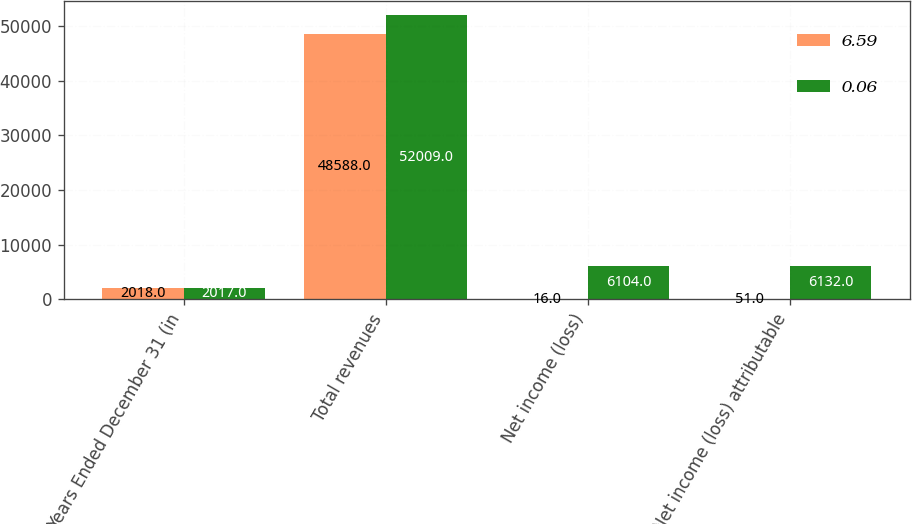Convert chart. <chart><loc_0><loc_0><loc_500><loc_500><stacked_bar_chart><ecel><fcel>Years Ended December 31 (in<fcel>Total revenues<fcel>Net income (loss)<fcel>Net income (loss) attributable<nl><fcel>6.59<fcel>2018<fcel>48588<fcel>16<fcel>51<nl><fcel>0.06<fcel>2017<fcel>52009<fcel>6104<fcel>6132<nl></chart> 